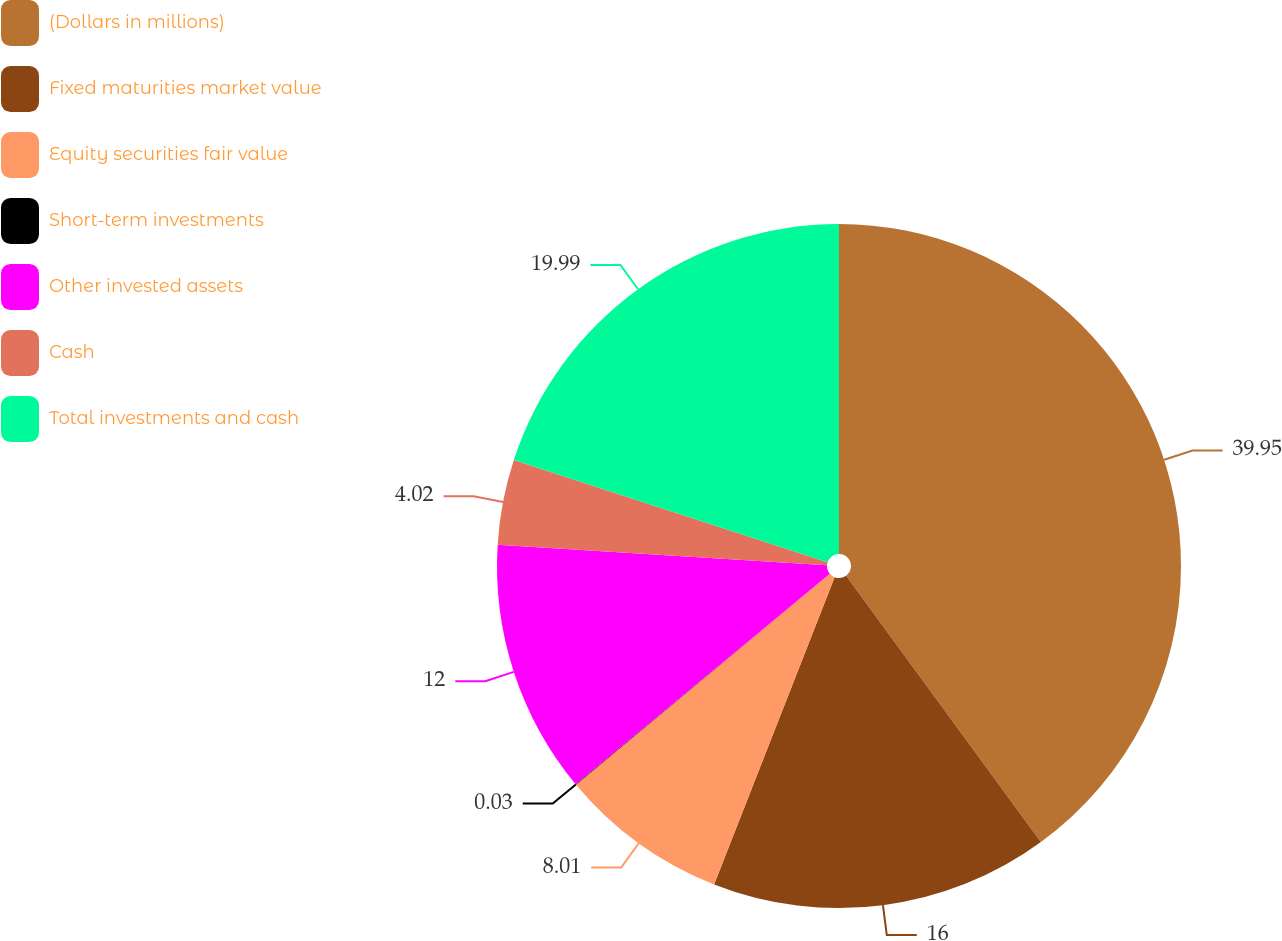<chart> <loc_0><loc_0><loc_500><loc_500><pie_chart><fcel>(Dollars in millions)<fcel>Fixed maturities market value<fcel>Equity securities fair value<fcel>Short-term investments<fcel>Other invested assets<fcel>Cash<fcel>Total investments and cash<nl><fcel>39.95%<fcel>16.0%<fcel>8.01%<fcel>0.03%<fcel>12.0%<fcel>4.02%<fcel>19.99%<nl></chart> 